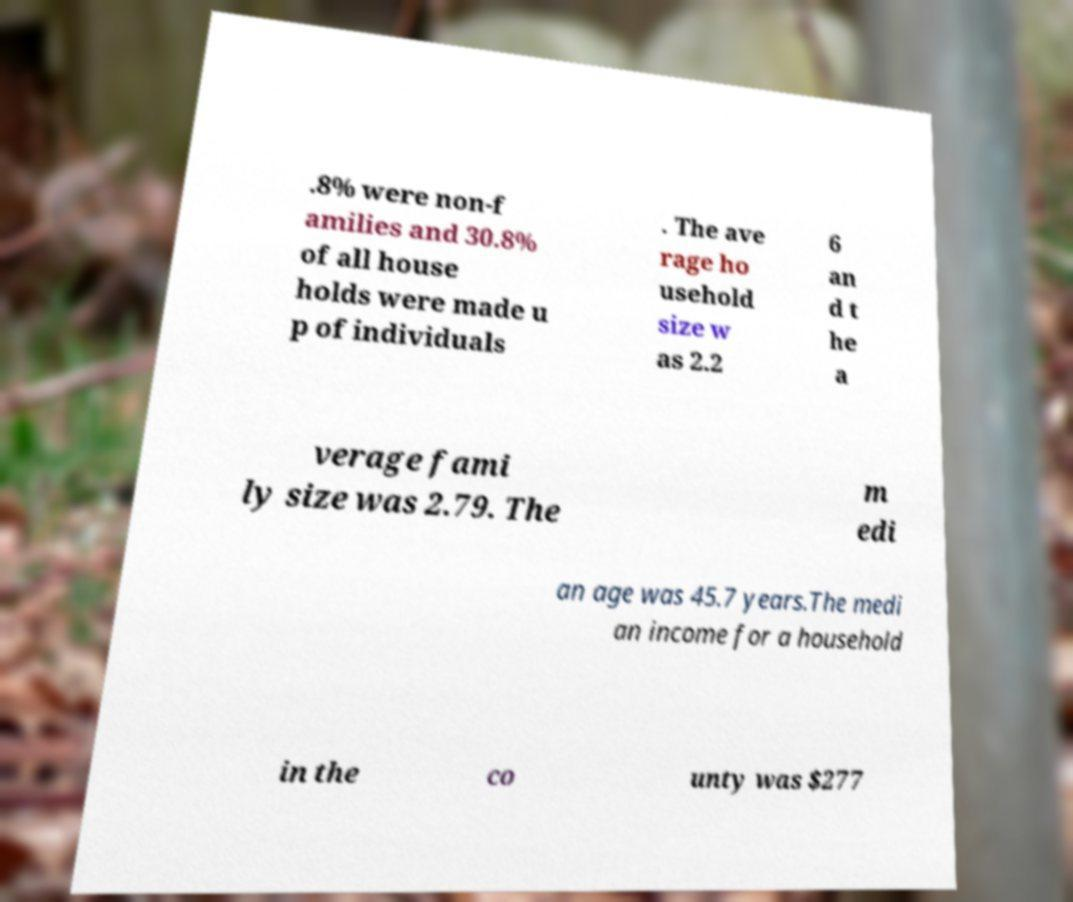There's text embedded in this image that I need extracted. Can you transcribe it verbatim? .8% were non-f amilies and 30.8% of all house holds were made u p of individuals . The ave rage ho usehold size w as 2.2 6 an d t he a verage fami ly size was 2.79. The m edi an age was 45.7 years.The medi an income for a household in the co unty was $277 